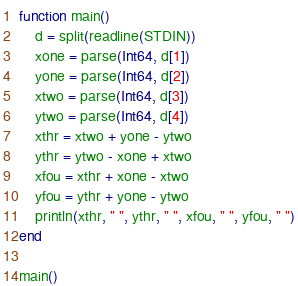Convert code to text. <code><loc_0><loc_0><loc_500><loc_500><_Julia_>function main()
	d = split(readline(STDIN))
	xone = parse(Int64, d[1])
	yone = parse(Int64, d[2])
	xtwo = parse(Int64, d[3])
	ytwo = parse(Int64, d[4])
	xthr = xtwo + yone - ytwo
	ythr = ytwo - xone + xtwo
	xfou = xthr + xone - xtwo
	yfou = ythr + yone - ytwo
	println(xthr, " ", ythr, " ", xfou, " ", yfou, " ")
end

main()</code> 